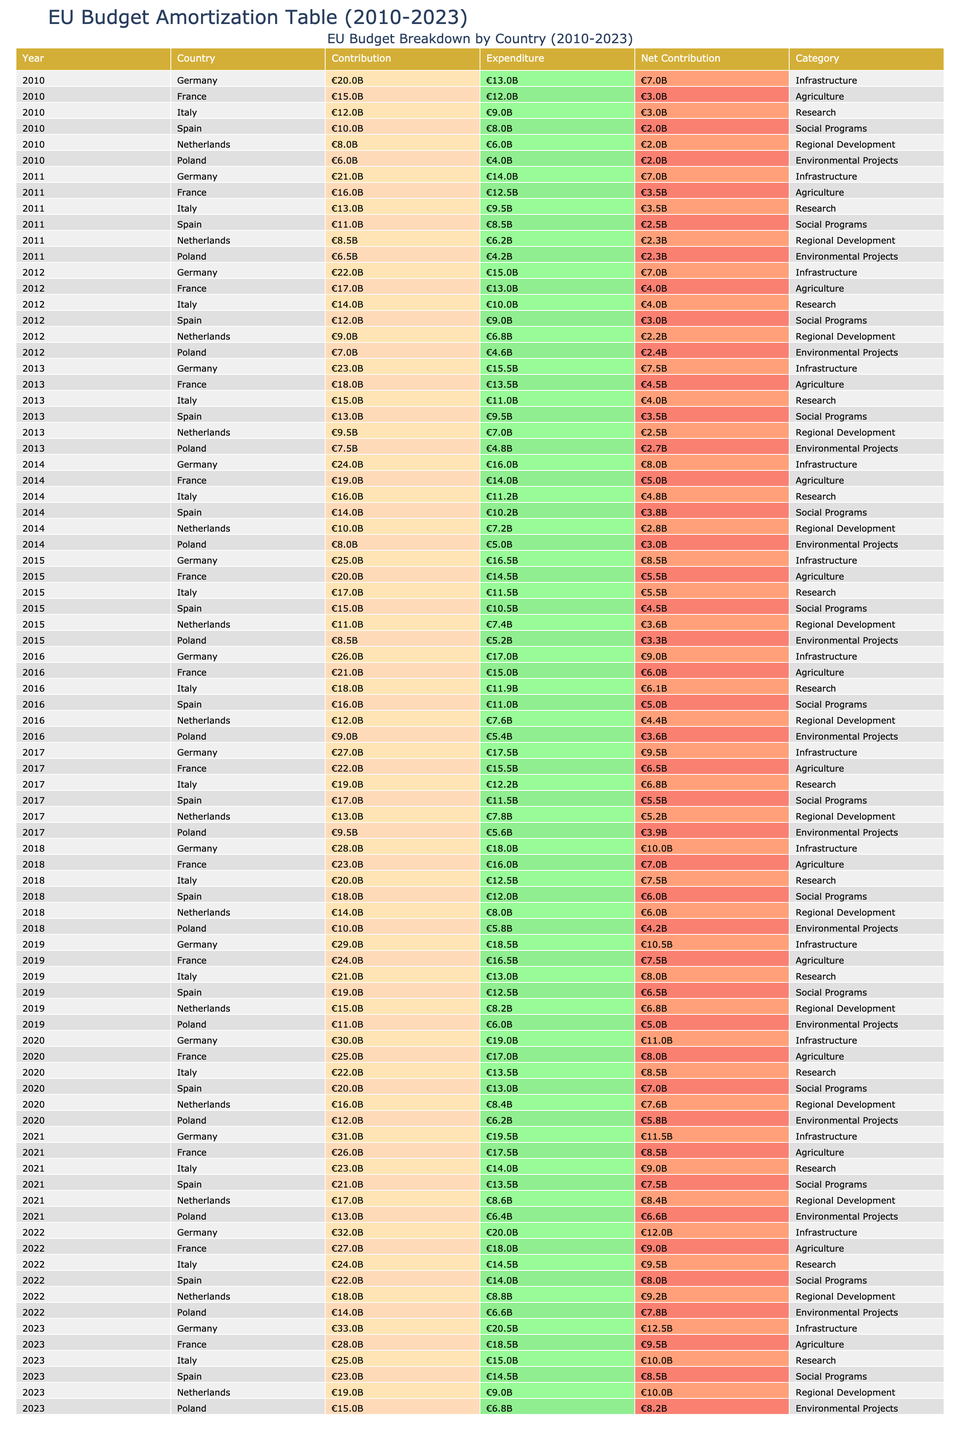What is the total contribution from Germany over the years 2010 to 2023? To find the total contribution from Germany, we need to sum up the contributions listed for each year from 2010 to 2023. The contributions are: €20B (2010) + €21B (2011) + €22B (2012) + €23B (2013) + €24B (2014) + €25B (2015) + €26B (2016) + €27B (2017) + €28B (2018) + €29B (2019) + €30B (2020) + €31B (2021) + €32B (2022) + €33B (2023). Adding these gives us €20 + €21 + €22 + €23 + €24 + €25 + €26 + €27 + €28 + €29 + €30 + €31 + €32 + €33 = €390 billion.
Answer: €390 billion Which year had the highest net contribution for France? To determine the year with the highest net contribution for France, we will check the 'Net Contribution' column for France across all the years. The values for years 2010 to 2023 are: €3B (2010), €3.5B (2011), €4B (2012), €4.5B (2013), €5B (2014), €5.5B (2015), €6B (2016), €6.5B (2017), €7B (2018), €7.5B (2019), €8B (2020), €8.5B (2021), €9B (2022), €9.5B (2023). The highest value is €9.5 billion in 2023.
Answer: 2023 Did Italy's contributions exceed its expenditures in any year? We will check the 'Contribution' and 'Expenditure' columns for Italy across all years. Comparison for each year shows: 2010 (€12B > €9B), 2011 (€13B > €9.5B), 2012 (€14B > €10B), 2013 (€15B > €11B), 2014 (€16B > €11.2B), 2015 (€17B > €11.5B), 2016 (€18B > €11.9B), 2017 (€19B > €12.2B), 2018 (€20B > €12.5B), 2019 (€21B > €13B), 2020 (€22B > €13.5B), 2021 (€23B > €14B), 2022 (€24B > €14.5B), 2023 (€25B > €15B). In every year, contributions exceeded expenditures.
Answer: Yes What is the average net contribution for Poland from 2010 to 2023? To calculate the average net contribution for Poland, we first sum the net contributions for each year: €2B (2010) + €2.3B (2011) + €2.4B (2012) + €2.7B (2013) + €3B (2014) + €3.3B (2015) + €3.6B (2016) + €3.9B (2017) + €4.2B (2018) + €5B (2019) + €5.8B (2020) + €6.6B (2021) + €7.8B (2022) + €8.2B (2023). This totals €56.8 billion. There are 14 years, so we divide by 14: €56.8 billion / 14 = €4.057 billion.
Answer: €4.057 billion Which category had the lowest total expenditure in 2019? We will look at the Expenditure column for 2019 and identify the expenditure for each category: Infrastructure (€18.5B), Agriculture (€16.5B), Research (€13B), Social Programs (€12.5B), Regional Development (€8.2B), Environmental Projects (€6B). The category with the lowest total expenditure is Environmental Projects at €6 billion.
Answer: Environmental Projects 